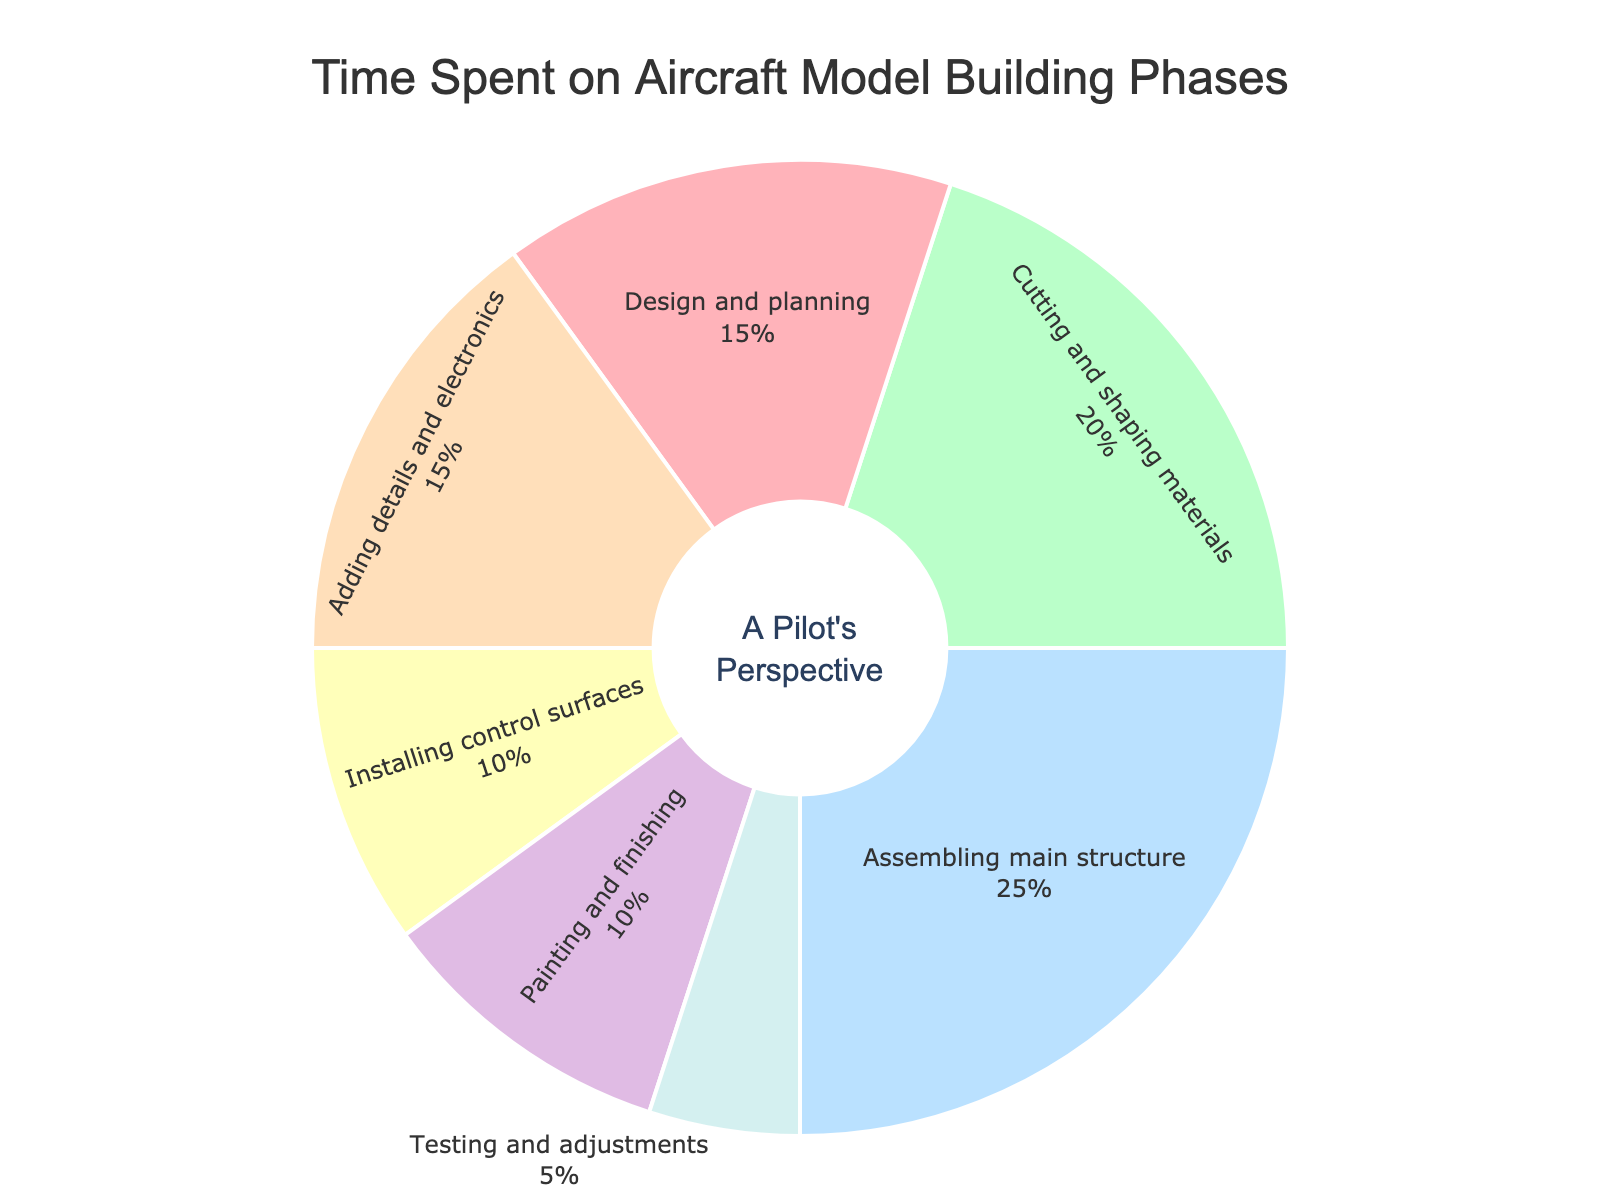What percentage of time is spent on assembling the main structure? From the figure, the portion labeled "Assembling main structure" represents this phase. The percentage next to it is 25%.
Answer: 25% Which phase takes up the least amount of time? The smallest slice of the pie indicates the phase with the least time spent, which is "Testing and adjustments" at 5%.
Answer: Testing and adjustments How much more time is spent on cutting and shaping materials compared to installing control surfaces? Cutting and shaping materials takes 20%, while installing control surfaces takes 10%. The difference is 20% - 10% = 10%.
Answer: 10% Which phase has the same amount of time as painting and finishing? From the figure, both "Painting and finishing" and "Installing control surfaces" occupy 10% each.
Answer: Installing control surfaces What is the combined percentage of time spent on adding details and electronics and painting and finishing? Adding details and electronics takes 15%, and painting and finishing takes 10%. Combined, it's 15% + 10% = 25%.
Answer: 25% Which two phases combined equal the time spent on assembling the main structure? The phase "Assembling main structure" takes 25%. Combining any two phases to equal this, we can use "Adding details and electronics" (15%) and "Design and planning" (15%), as 15% + 10% = 25%.
Answer: Design and planning and Painting and finishing If time spent on painting and finishing and testing and adjustments were combined, what would be their new percentage of the total time? Painting and finishing is 10%, and testing and adjustments is 5%. Combined, they are 10% + 5% = 15%.
Answer: 15% Which phase has a smaller percentage than adding details and electronics but larger than testing and adjustments? Adding details and electronics is 15%, and testing and adjustments is 5%. The phase in between is "Painting and finishing" and "Installing control surfaces," both at 10%.
Answer: Painting and finishing or Installing control surfaces How many phases take up more than 10% of the total time? From the pie chart, "Design and planning" (15%), "Cutting and shaping materials" (20%), "Assembling main structure" (25%), and "Adding details and electronics" (15%) take up more than 10% of the time. There are 4 such phases.
Answer: 4 